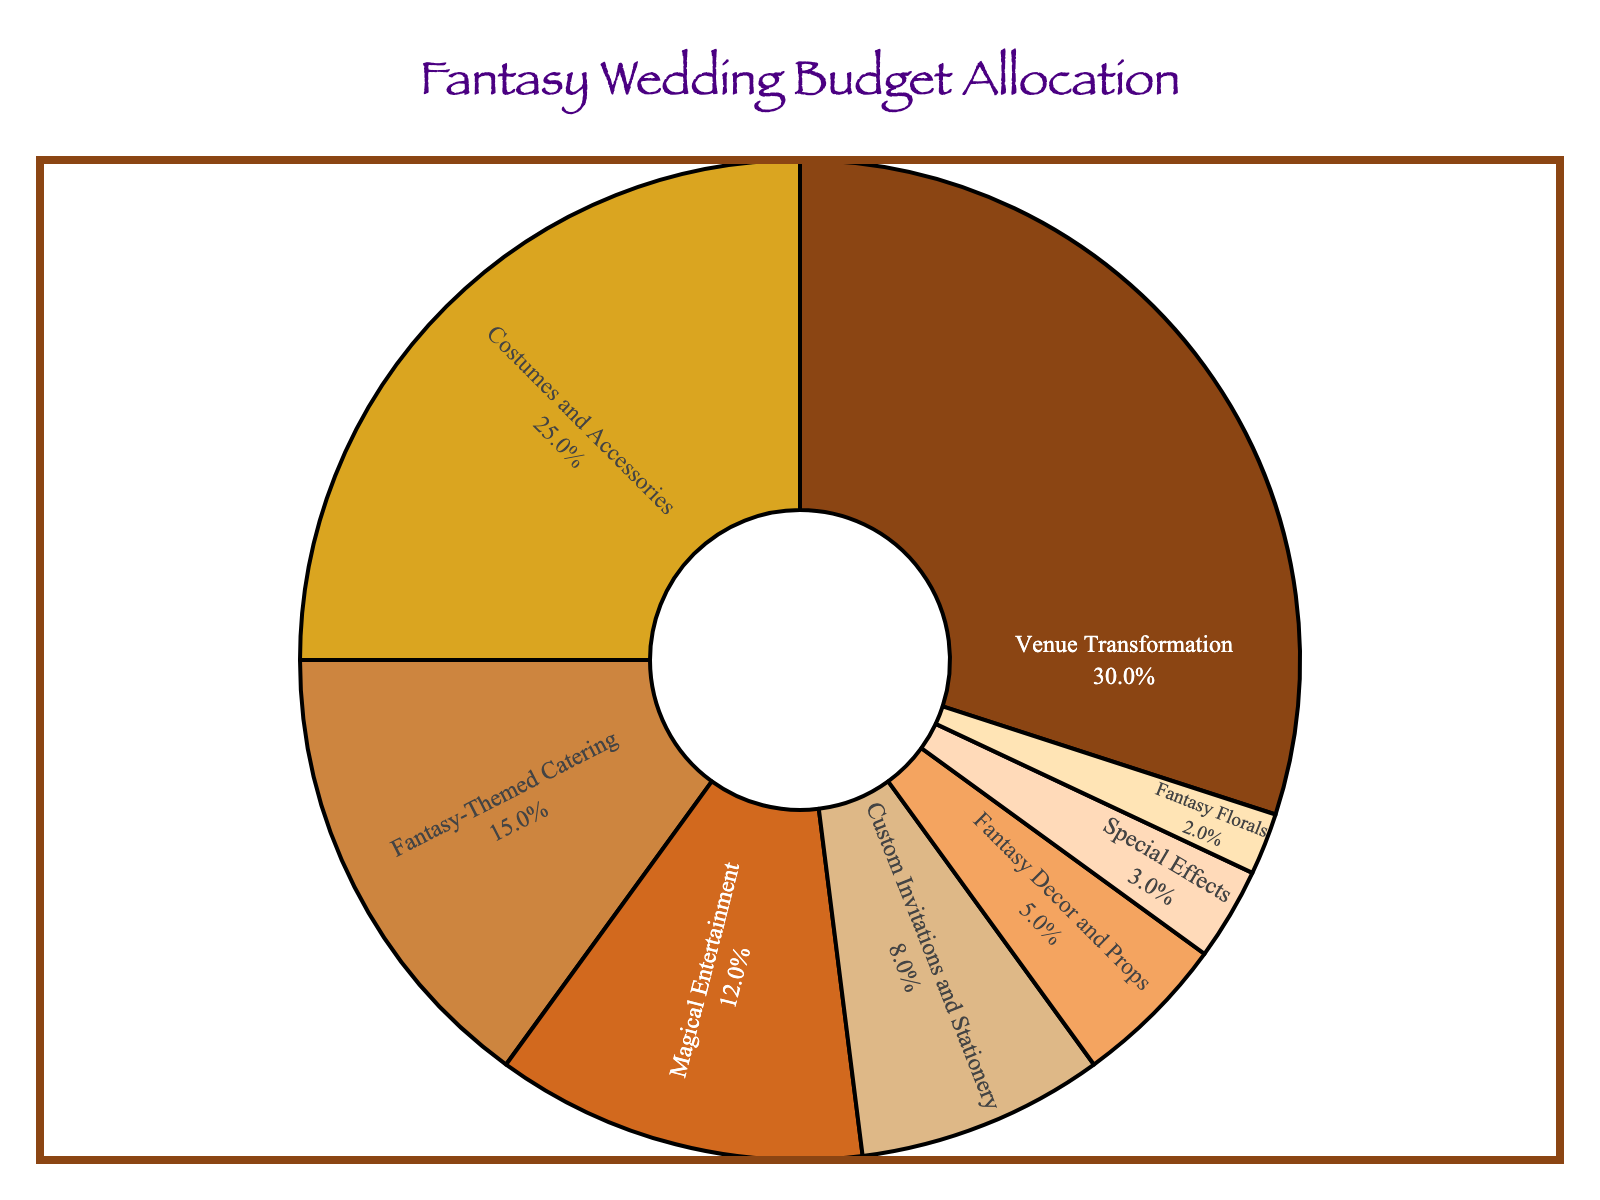What is the category with the largest budget allocation? The category with the largest budget allocation can be identified by finding the category with the highest percentage value in the pie chart. Here, Venue Transformation has the highest percentage at 30%.
Answer: Venue Transformation Which category has a smaller budget allocation: Costumes and Accessories or Fantasy-Themed Catering? By comparing the percentages, Costumes and Accessories has 25%, while Fantasy-Themed Catering has 15%. Therefore, Fantasy-Themed Catering has a smaller budget allocation.
Answer: Fantasy-Themed Catering What is the combined budget allocation for Custom Invitations and Stationery, and Fantasy Decor and Props? Sum the percentages of Custom Invitations and Stationery and Fantasy Decor and Props: 8% + 5% = 13%.
Answer: 13% Which category has the smallest budget allocation, and what is its percentage? The category with the smallest budget allocation can be identified by finding the category with the lowest percentage value in the pie chart. Fantasy Florals has the smallest percentage at 2%.
Answer: Fantasy Florals, 2% How much more is allocated to Magical Entertainment compared to Special Effects? Subtract the percentage of Special Effects from Magical Entertainment: 12% - 3% = 9%.
Answer: 9% What is the average budget allocation percentage for the top three categories? The top three categories by percentage are Venue Transformation (30%), Costumes and Accessories (25%), and Fantasy-Themed Catering (15%). Calculate the average: (30% + 25% + 15%) / 3 = 70% / 3 ≈ 23.3%.
Answer: 23.3% Is more budget allocated to Fantasy Florals or to Special Effects? By comparing the percentages, Fantasy Florals has 2%, while Special Effects has 3%. Therefore, more budget is allocated to Special Effects.
Answer: Special Effects What percentage of the budget is allocated to elements other than Venue Transformation? Subtract the percentage of Venue Transformation from 100%: 100% - 30% = 70%.
Answer: 70% Combine the percentages of categories with less than 10% allocation each. What is their total? Combine percentages for categories with less than 10%: Fantasy-Themed Catering (15%), Magical Entertainment (12%), Custom Invitations and Stationery (8%), Fantasy Decor and Props (5%), Special Effects (3%), and Fantasy Florals (2%). Sum these up: 15% + 12% + 8% + 5% + 3% + 2% = 45%.
Answer: 45% What is the difference between the budget allocations for the top two categories and the bottom two categories? Top two categories: Venue Transformation (30%) and Costumes and Accessories (25%). Bottom two categories: Special Effects (3%) and Fantasy Florals (2%). Sum of top two: 30% + 25% = 55%. Sum of bottom two: 3% + 2% = 5%. Difference: 55% - 5% = 50%.
Answer: 50% 